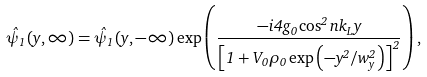Convert formula to latex. <formula><loc_0><loc_0><loc_500><loc_500>\hat { \psi } _ { 1 } ( y , \infty ) = \hat { \psi } _ { 1 } ( y , - \infty ) \exp \left ( \frac { - i 4 g _ { 0 } \cos ^ { 2 } n k _ { L } y } { \left [ 1 + V _ { 0 } \rho _ { 0 } \exp \left ( - y ^ { 2 } / w _ { y } ^ { 2 } \right ) \right ] ^ { 2 } } \right ) ,</formula> 